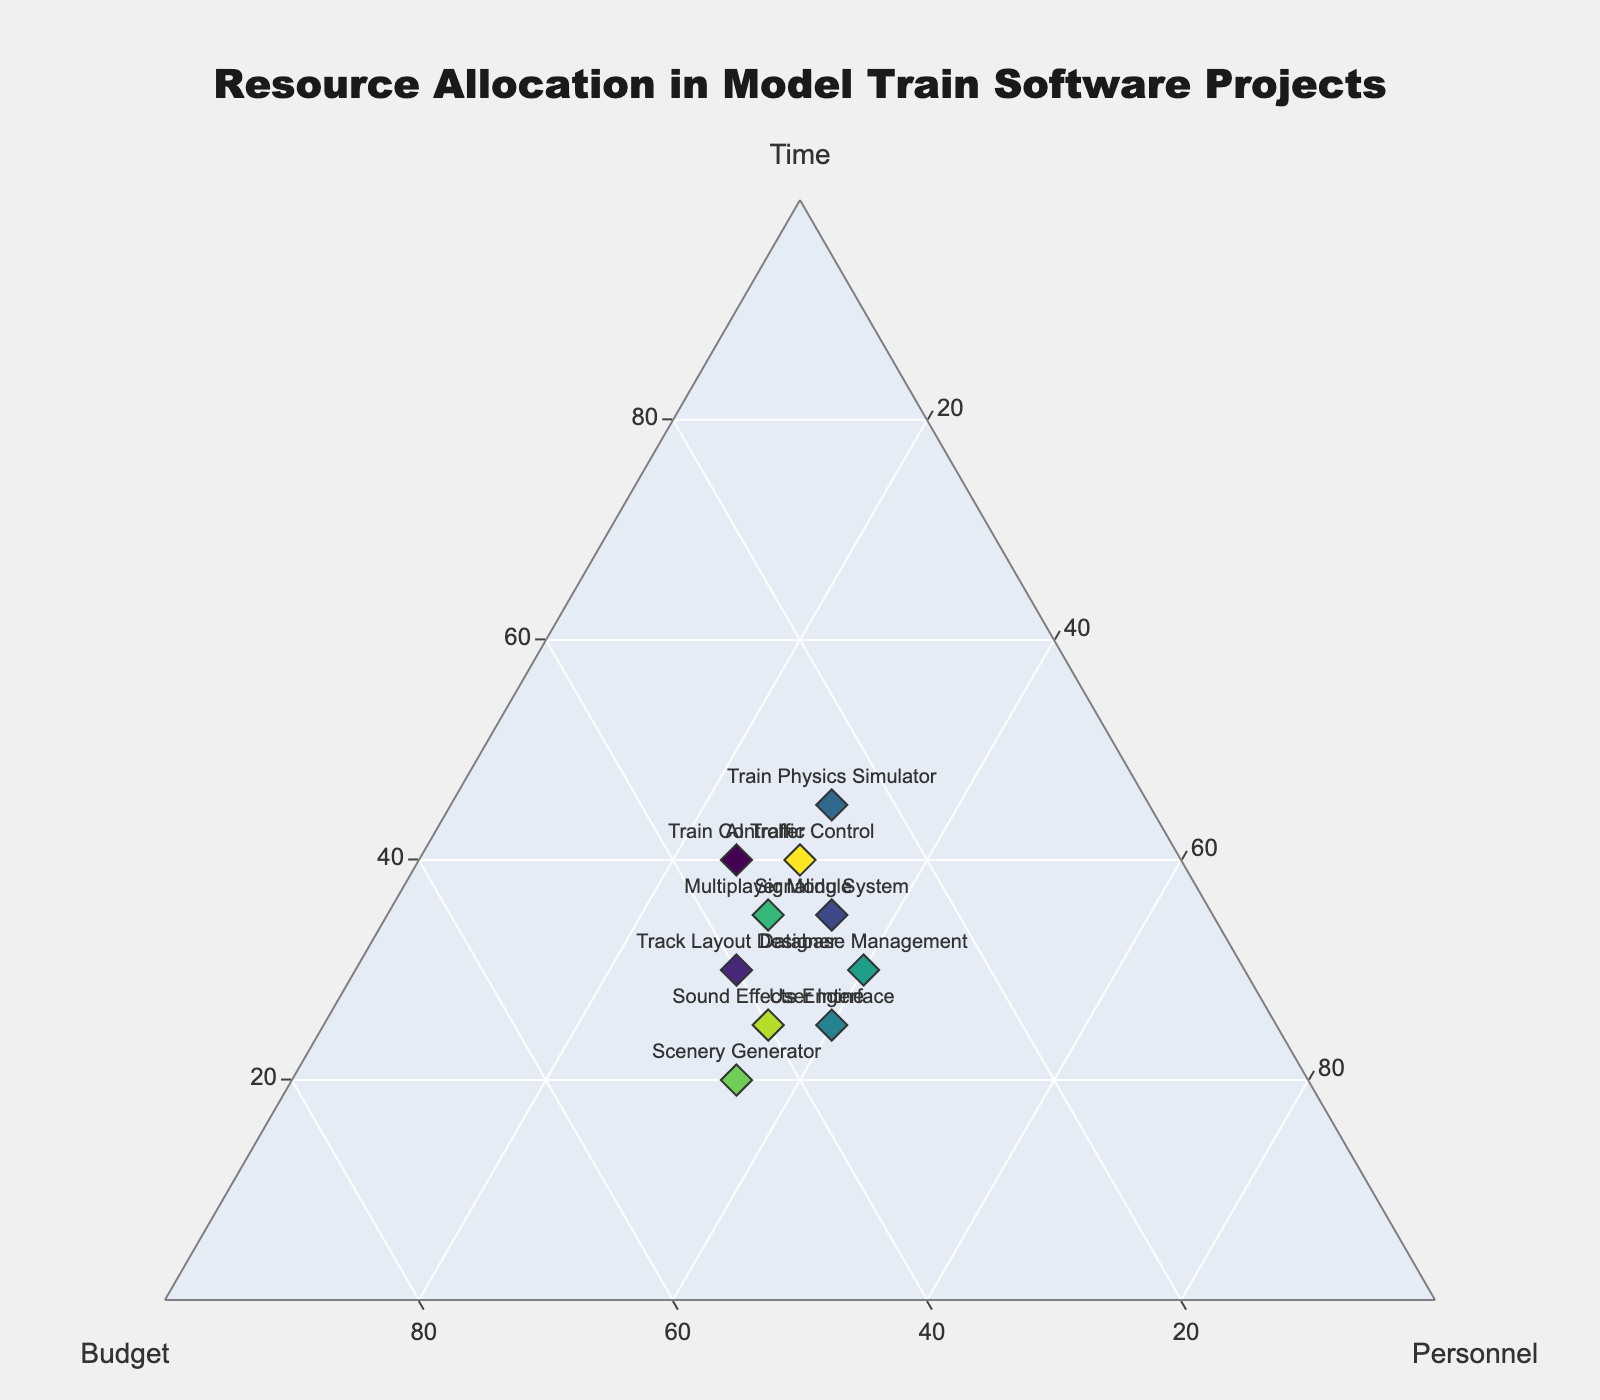Which project is closest to having an equal allocation of resources in terms of time, budget, and personnel? To determine which project is closest to having an equal allocation of resources, we should look for a data point that is near the center of the ternary plot where all three axes intersect, meaning each value is around 33%. Inspecting the plot, we see that the "Signaling System" project has time, budget, and personnel values close to 33% each.
Answer: Signaling System Which project has the highest allocation of personnel? To find the project with the highest allocation of personnel, we look for the data point that is closest to the Personnel axis. In the plot, "User Interface" and "Database Management" both have the highest allocation for personnel at 40%.
Answer: User Interface and Database Management What is the average allocation of budget across all projects? To find the average budget allocation, we sum all the budget percentages and then divide by the number of projects. The total for the Budget column is 345. Dividing this by 10 (the number of projects), the average is 34.5%.
Answer: 34.5% How does the time allocation for the "Train Physics Simulator" compare to the "Scenery Generator"? We need to compare the Time values for these two projects. "Train Physics Simulator" has a Time allocation of 45%, while "Scenery Generator" has 20%. Therefore, the "Train Physics Simulator" has a higher time allocation.
Answer: Train Physics Simulator has a higher time allocation Which project strikes a balance between higher budget and higher personnel allocation? To find this, we look for the project data point that is closer to the Budget and Personnel axis vertices. "User Interface" stands out with a Budget allocation of 35% and Personnel allocation of 40%, balancing both resources.
Answer: User Interface What is the total amount of time allocated across all projects? To find the total time allocation, we sum all the values in the Time column. Adding these gives us 40 + 30 + 35 + 45 + 25 + 30 + 35 + 20 + 25 + 40 = 325%.
Answer: 325% Which project has the least budget allocation and how does it affect the other allocations? The project with the least budget allocation is the "Train Physics Simulator" with 25%. Examining its values, we see it compensates with higher time allocation (45%) and medium personnel allocation (30%).
Answer: Train Physics Simulator Is there any project with an almost balanced but slightly higher time allocation? The project with time close to one-third but a bit higher would be around 33% but slightly more. "Train Controller" with 40% time and "AI Traffic Control" with 40% time are close but slightly higher.
Answer: Train Controller and AI Traffic Control How do the projects "Train Controller" and "Track Layout Designer" compare in terms of budget and personnel? "Train Controller" has a Budget of 35% and Personnel of 25%. "Track Layout Designer" has Budget of 40% and Personnel of 30%. Thus, "Track Layout Designer" has a higher budget and personnel allocation compared to "Train Controller".
Answer: Track Layout Designer has higher budget and personnel What is the variance in time allocation among all projects? Variance helps understand the spread of the time allocation values. The Time values are [40, 30, 35, 45, 25, 30, 35, 20, 25, 40]. Calculating the mean (32.5) first, then the variance: sum((value - mean)^2) / N = ((40-32.5)^2 + (30-32.5)^2 + (35-32.5)^2 + (45-32.5)^2 + (25-32.5)^2 + (30-32.5)^2 + (35-32.5)^2 + (20-32.5)^2 + (25-32.5)^2 + (40-32.5)^2) / 10 = 48.75.
Answer: 48.75 